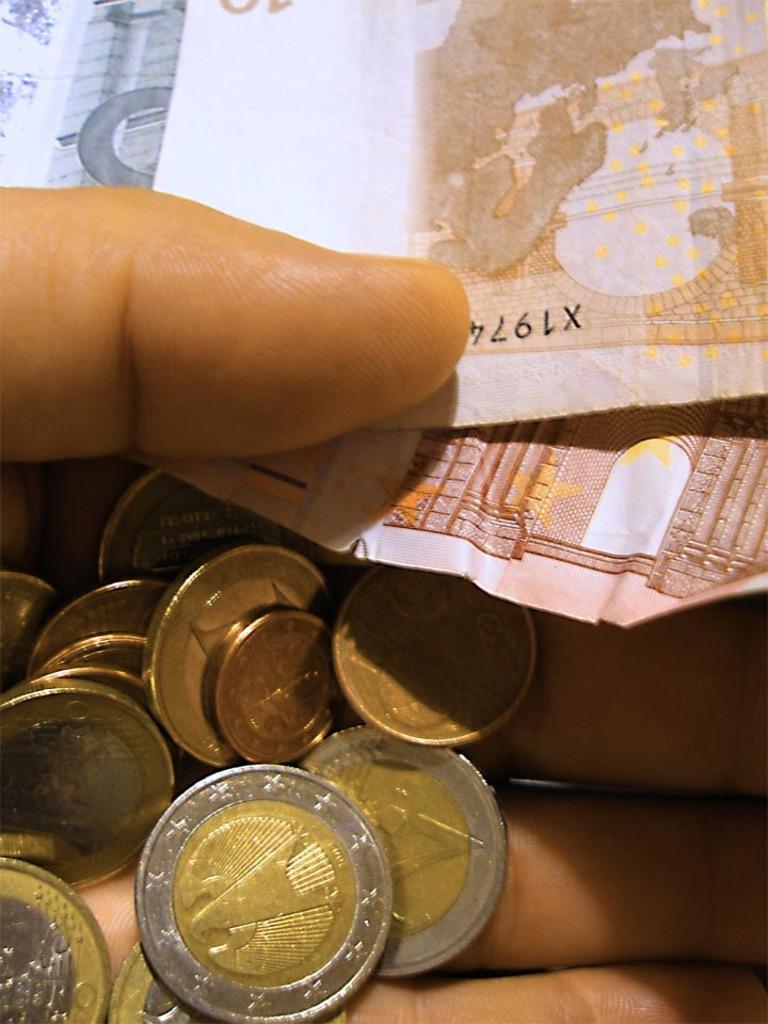Is x1974 a type of code?
Make the answer very short. Unanswerable. 